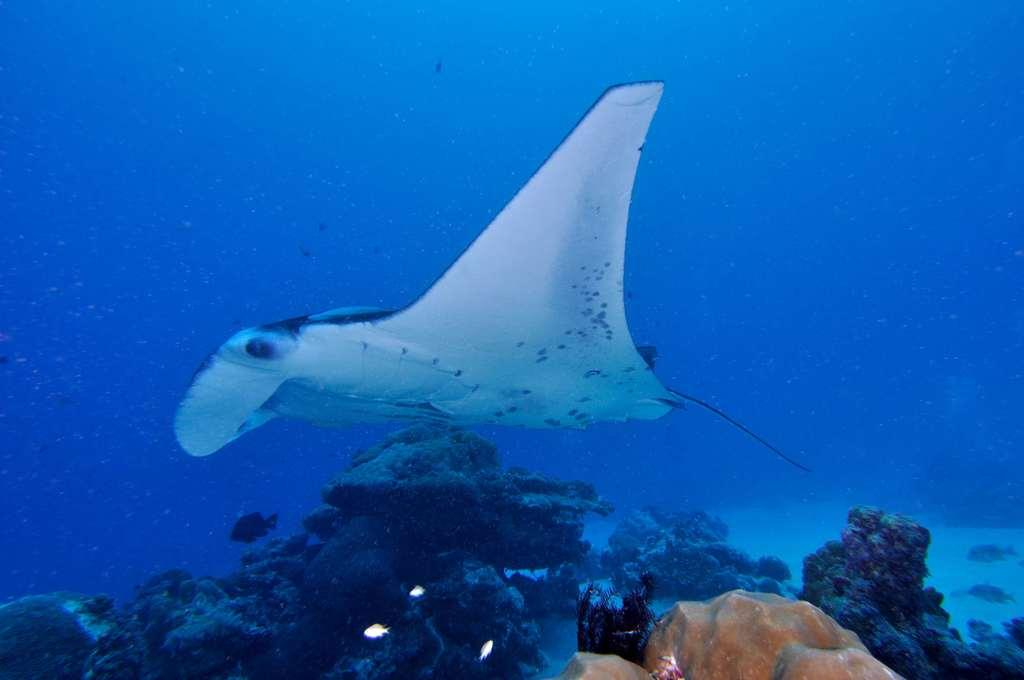What type of animal can be seen in the water in the image? There is a fish in the water in the image. What is at the bottom of the water in the image? There are stones and algae at the bottom of the water in the image. What type of vegetation is present in the water in the image? There are aquatic plants in the water in the image. What type of payment is required to enter the mind of the fish in the image? There is no mention of a mind or payment in the image; it simply depicts a fish in the water with stones, algae, and aquatic plants at the bottom. 